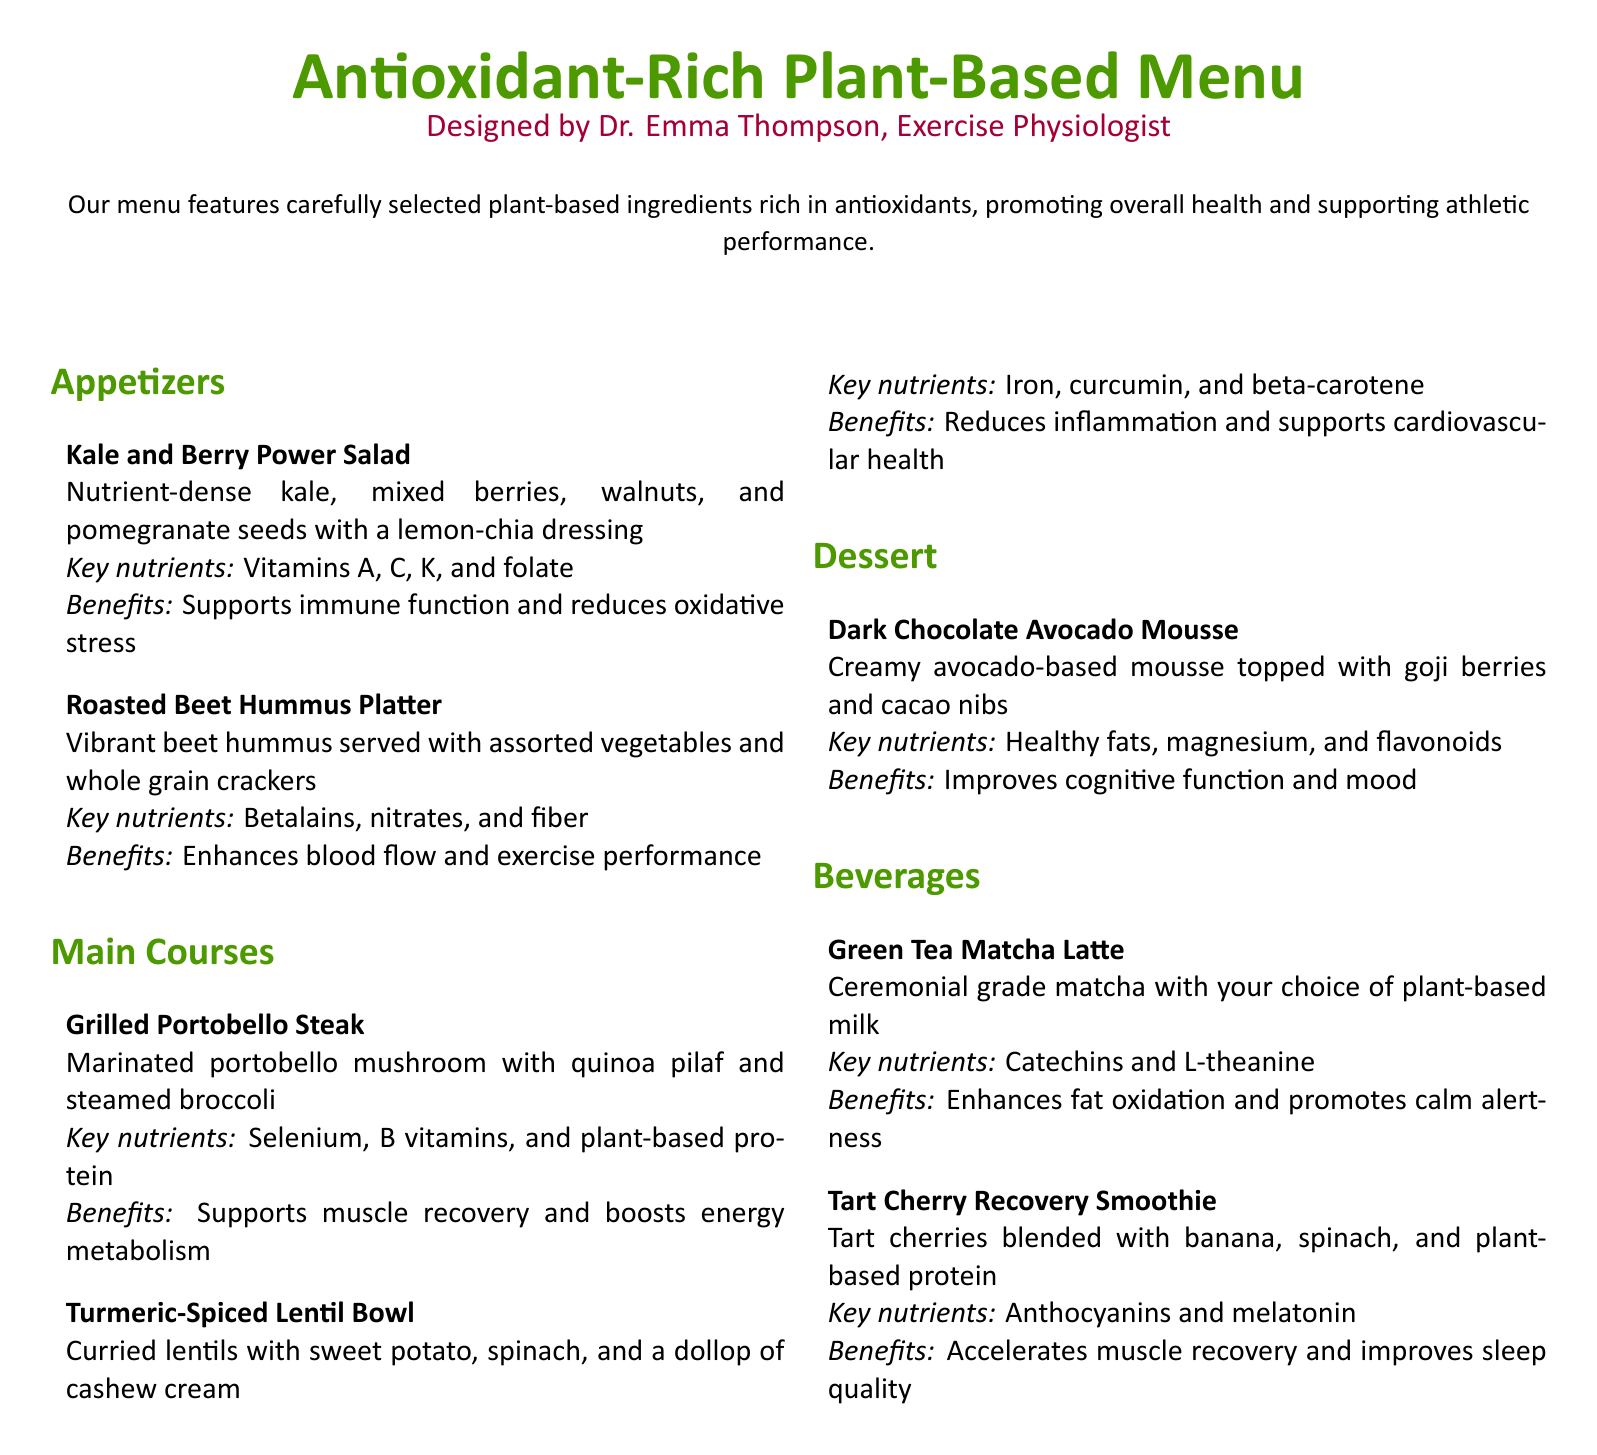what is the title of the menu? The title of the menu is prominently displayed at the top of the document.
Answer: Antioxidant-Rich Plant-Based Menu who designed the menu? The designer's name is mentioned below the title.
Answer: Dr. Emma Thompson what are the key nutrients in the Kale and Berry Power Salad? The key nutrients are listed under each dish in the menu.
Answer: Vitamins A, C, K, and folate what is the benefit of the Dark Chocolate Avocado Mousse? Benefits are outlined for each menu item.
Answer: Improves cognitive function and mood how many appetizers are listed on the menu? The number of items can be counted in the appetizers section.
Answer: 2 which beverage contains catechins? Each beverage lists its key nutrients.
Answer: Green Tea Matcha Latte what is a key nutrient found in the Roasted Beet Hummus Platter? Key nutrients for each dish are provided in the document.
Answer: Betalains what is the main ingredient of the Turmeric-Spiced Lentil Bowl? The dish's main ingredients are described in its name and details.
Answer: Lentils what type of dressing is used in the Kale and Berry Power Salad? The dressing information is provided under the appetizers section.
Answer: Lemon-chia dressing 